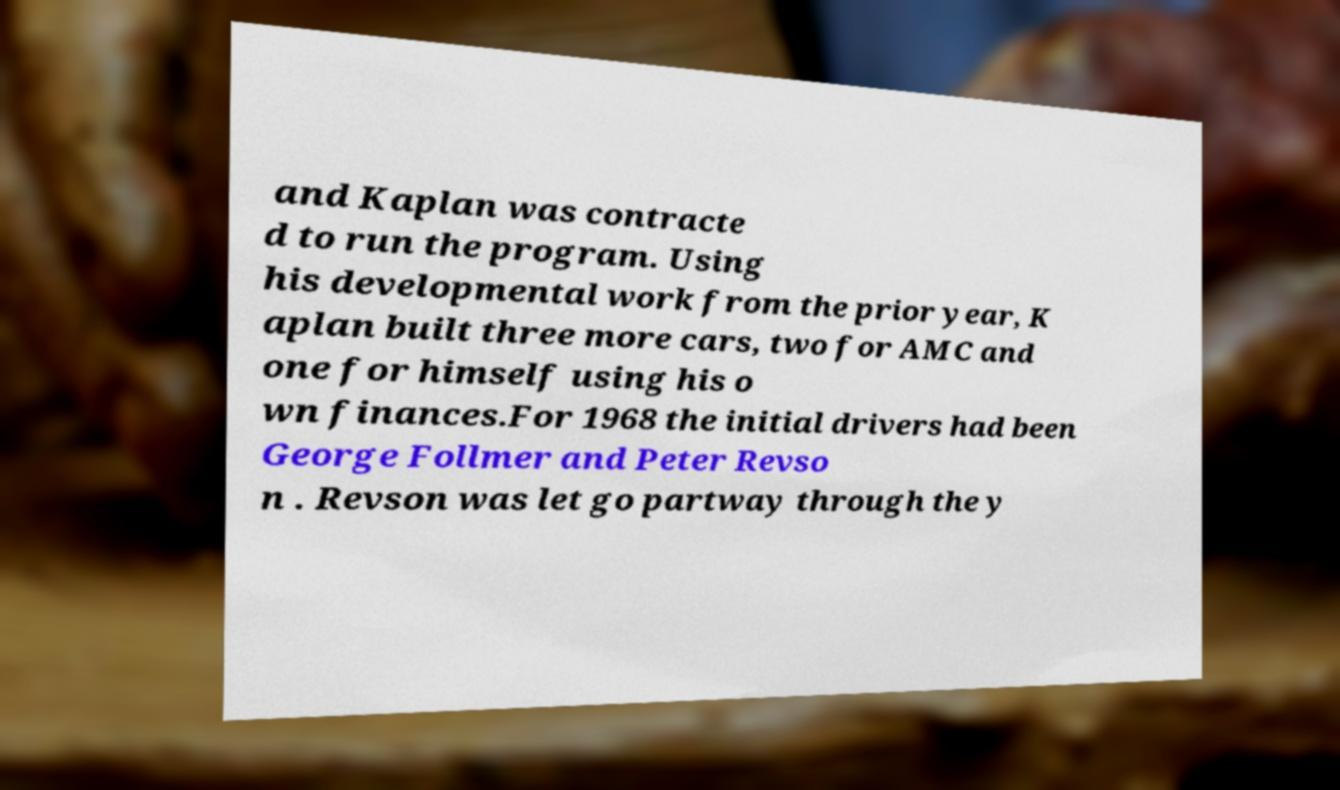Can you read and provide the text displayed in the image?This photo seems to have some interesting text. Can you extract and type it out for me? and Kaplan was contracte d to run the program. Using his developmental work from the prior year, K aplan built three more cars, two for AMC and one for himself using his o wn finances.For 1968 the initial drivers had been George Follmer and Peter Revso n . Revson was let go partway through the y 